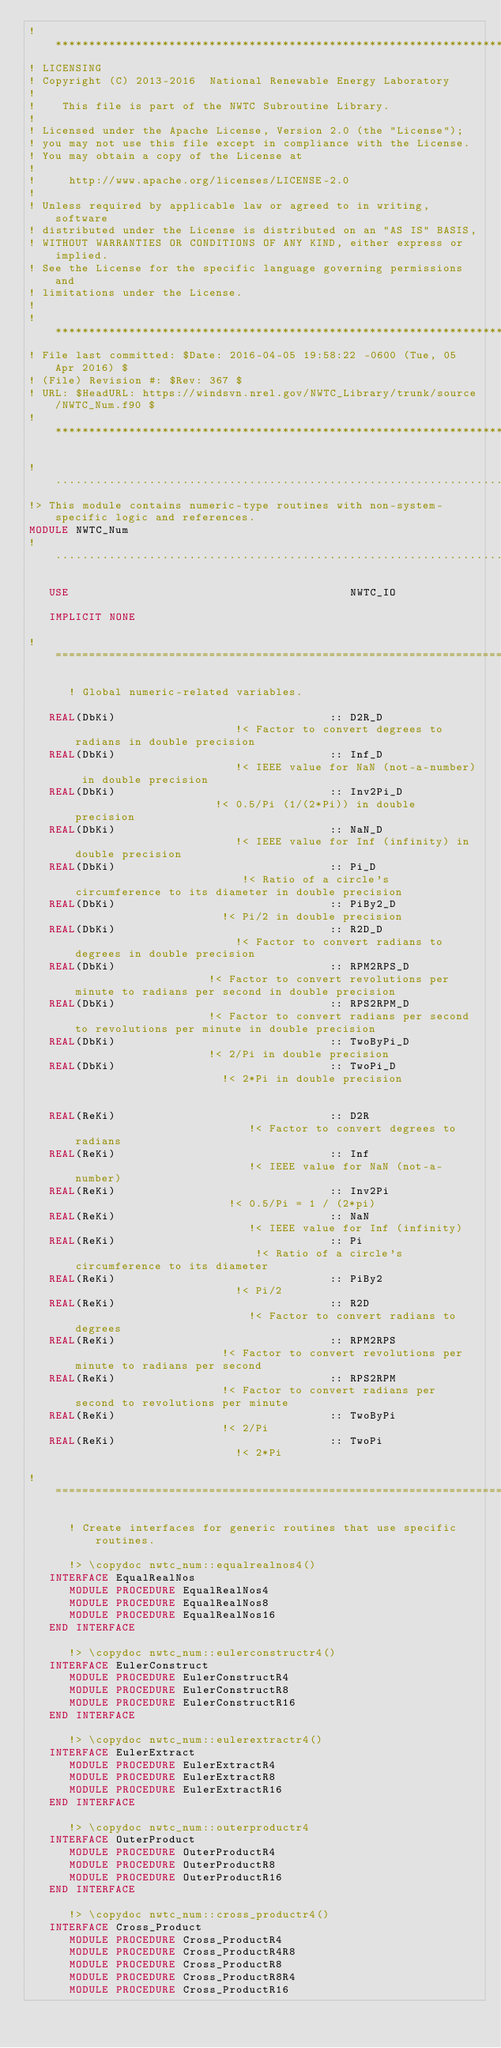<code> <loc_0><loc_0><loc_500><loc_500><_FORTRAN_>!**********************************************************************************************************************************
! LICENSING
! Copyright (C) 2013-2016  National Renewable Energy Laboratory
!
!    This file is part of the NWTC Subroutine Library.
!
! Licensed under the Apache License, Version 2.0 (the "License");
! you may not use this file except in compliance with the License.
! You may obtain a copy of the License at
!
!     http://www.apache.org/licenses/LICENSE-2.0
!
! Unless required by applicable law or agreed to in writing, software
! distributed under the License is distributed on an "AS IS" BASIS,
! WITHOUT WARRANTIES OR CONDITIONS OF ANY KIND, either express or implied.
! See the License for the specific language governing permissions and
! limitations under the License.
!
!**********************************************************************************************************************************
! File last committed: $Date: 2016-04-05 19:58:22 -0600 (Tue, 05 Apr 2016) $
! (File) Revision #: $Rev: 367 $
! URL: $HeadURL: https://windsvn.nrel.gov/NWTC_Library/trunk/source/NWTC_Num.f90 $
!**********************************************************************************************************************************

!..................................................................................................................................
!> This module contains numeric-type routines with non-system-specific logic and references.
MODULE NWTC_Num
!..................................................................................................................................
   
   USE                                          NWTC_IO

   IMPLICIT NONE

!=======================================================================

      ! Global numeric-related variables.

   REAL(DbKi)                                :: D2R_D                         !< Factor to convert degrees to radians in double precision
   REAL(DbKi)                                :: Inf_D                         !< IEEE value for NaN (not-a-number) in double precision
   REAL(DbKi)                                :: Inv2Pi_D                      !< 0.5/Pi (1/(2*Pi)) in double precision
   REAL(DbKi)                                :: NaN_D                         !< IEEE value for Inf (infinity) in double precision
   REAL(DbKi)                                :: Pi_D                          !< Ratio of a circle's circumference to its diameter in double precision
   REAL(DbKi)                                :: PiBy2_D                       !< Pi/2 in double precision
   REAL(DbKi)                                :: R2D_D                         !< Factor to convert radians to degrees in double precision
   REAL(DbKi)                                :: RPM2RPS_D                     !< Factor to convert revolutions per minute to radians per second in double precision
   REAL(DbKi)                                :: RPS2RPM_D                     !< Factor to convert radians per second to revolutions per minute in double precision
   REAL(DbKi)                                :: TwoByPi_D                     !< 2/Pi in double precision
   REAL(DbKi)                                :: TwoPi_D                       !< 2*Pi in double precision


   REAL(ReKi)                                :: D2R                           !< Factor to convert degrees to radians
   REAL(ReKi)                                :: Inf                           !< IEEE value for NaN (not-a-number)
   REAL(ReKi)                                :: Inv2Pi                        !< 0.5/Pi = 1 / (2*pi)
   REAL(ReKi)                                :: NaN                           !< IEEE value for Inf (infinity)
   REAL(ReKi)                                :: Pi                            !< Ratio of a circle's circumference to its diameter
   REAL(ReKi)                                :: PiBy2                         !< Pi/2
   REAL(ReKi)                                :: R2D                           !< Factor to convert radians to degrees
   REAL(ReKi)                                :: RPM2RPS                       !< Factor to convert revolutions per minute to radians per second
   REAL(ReKi)                                :: RPS2RPM                       !< Factor to convert radians per second to revolutions per minute
   REAL(ReKi)                                :: TwoByPi                       !< 2/Pi
   REAL(ReKi)                                :: TwoPi                         !< 2*Pi

!=======================================================================

      ! Create interfaces for generic routines that use specific routines.

      !> \copydoc nwtc_num::equalrealnos4()
   INTERFACE EqualRealNos
      MODULE PROCEDURE EqualRealNos4
      MODULE PROCEDURE EqualRealNos8
      MODULE PROCEDURE EqualRealNos16
   END INTERFACE

      !> \copydoc nwtc_num::eulerconstructr4()
   INTERFACE EulerConstruct
      MODULE PROCEDURE EulerConstructR4
      MODULE PROCEDURE EulerConstructR8
      MODULE PROCEDURE EulerConstructR16
   END INTERFACE
   
      !> \copydoc nwtc_num::eulerextractr4()
   INTERFACE EulerExtract
      MODULE PROCEDURE EulerExtractR4
      MODULE PROCEDURE EulerExtractR8
      MODULE PROCEDURE EulerExtractR16
   END INTERFACE
   
      !> \copydoc nwtc_num::outerproductr4
   INTERFACE OuterProduct
      MODULE PROCEDURE OuterProductR4
      MODULE PROCEDURE OuterProductR8
      MODULE PROCEDURE OuterProductR16
   END INTERFACE

      !> \copydoc nwtc_num::cross_productr4()
   INTERFACE Cross_Product
      MODULE PROCEDURE Cross_ProductR4
      MODULE PROCEDURE Cross_ProductR4R8
      MODULE PROCEDURE Cross_ProductR8
      MODULE PROCEDURE Cross_ProductR8R4
      MODULE PROCEDURE Cross_ProductR16</code> 